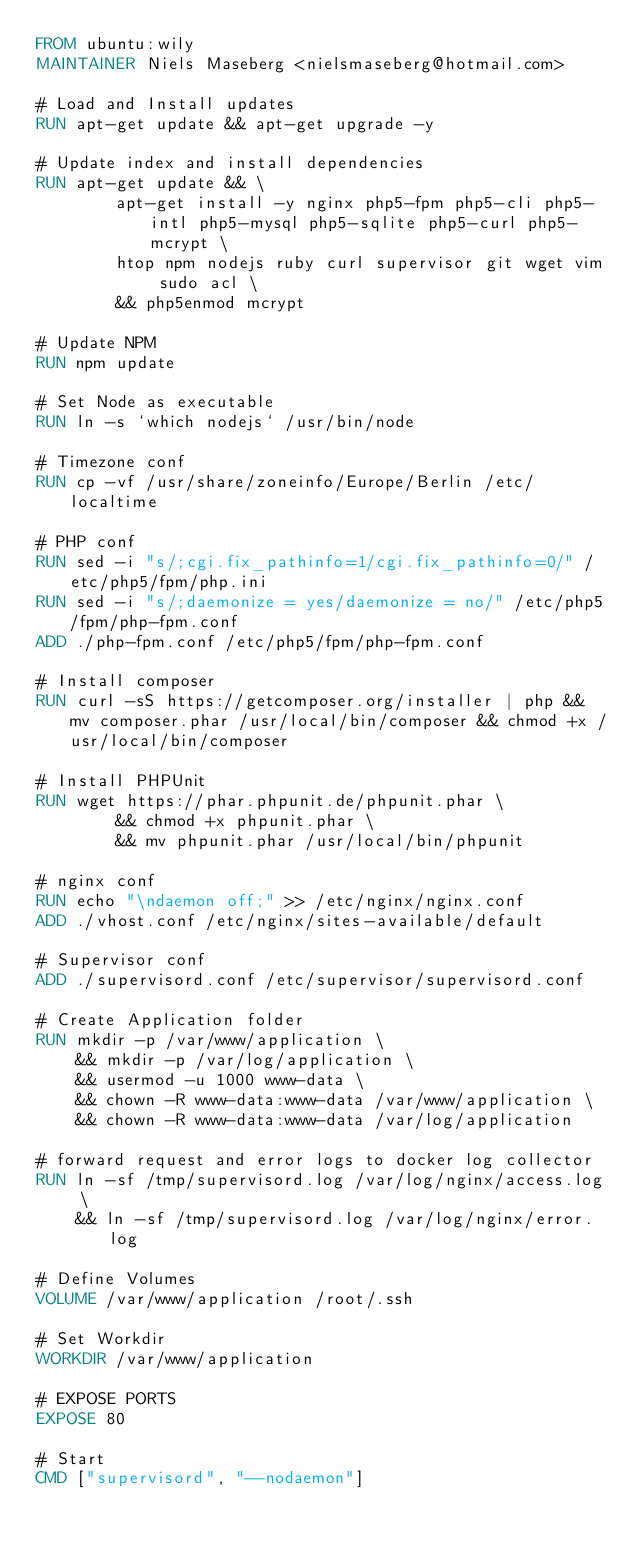Convert code to text. <code><loc_0><loc_0><loc_500><loc_500><_Dockerfile_>FROM ubuntu:wily
MAINTAINER Niels Maseberg <nielsmaseberg@hotmail.com>

# Load and Install updates
RUN apt-get update && apt-get upgrade -y

# Update index and install dependencies
RUN apt-get update && \
        apt-get install -y nginx php5-fpm php5-cli php5-intl php5-mysql php5-sqlite php5-curl php5-mcrypt \
        htop npm nodejs ruby curl supervisor git wget vim sudo acl \
        && php5enmod mcrypt

# Update NPM
RUN npm update

# Set Node as executable
RUN ln -s `which nodejs` /usr/bin/node

# Timezone conf
RUN cp -vf /usr/share/zoneinfo/Europe/Berlin /etc/localtime

# PHP conf
RUN sed -i "s/;cgi.fix_pathinfo=1/cgi.fix_pathinfo=0/" /etc/php5/fpm/php.ini
RUN sed -i "s/;daemonize = yes/daemonize = no/" /etc/php5/fpm/php-fpm.conf
ADD ./php-fpm.conf /etc/php5/fpm/php-fpm.conf

# Install composer
RUN curl -sS https://getcomposer.org/installer | php && mv composer.phar /usr/local/bin/composer && chmod +x /usr/local/bin/composer

# Install PHPUnit
RUN wget https://phar.phpunit.de/phpunit.phar \
        && chmod +x phpunit.phar \
        && mv phpunit.phar /usr/local/bin/phpunit

# nginx conf
RUN echo "\ndaemon off;" >> /etc/nginx/nginx.conf
ADD ./vhost.conf /etc/nginx/sites-available/default

# Supervisor conf
ADD ./supervisord.conf /etc/supervisor/supervisord.conf

# Create Application folder
RUN mkdir -p /var/www/application \
    && mkdir -p /var/log/application \
    && usermod -u 1000 www-data \
    && chown -R www-data:www-data /var/www/application \
    && chown -R www-data:www-data /var/log/application

# forward request and error logs to docker log collector
RUN ln -sf /tmp/supervisord.log /var/log/nginx/access.log \
    && ln -sf /tmp/supervisord.log /var/log/nginx/error.log

# Define Volumes
VOLUME /var/www/application /root/.ssh

# Set Workdir
WORKDIR /var/www/application

# EXPOSE PORTS
EXPOSE 80

# Start
CMD ["supervisord", "--nodaemon"]</code> 